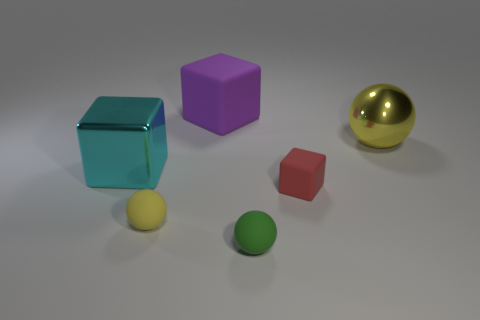There is a block that is behind the yellow shiny ball; is its size the same as the green thing? No, the block behind the yellow shiny ball is larger than the green thing, which appears to be a smaller sphere. 